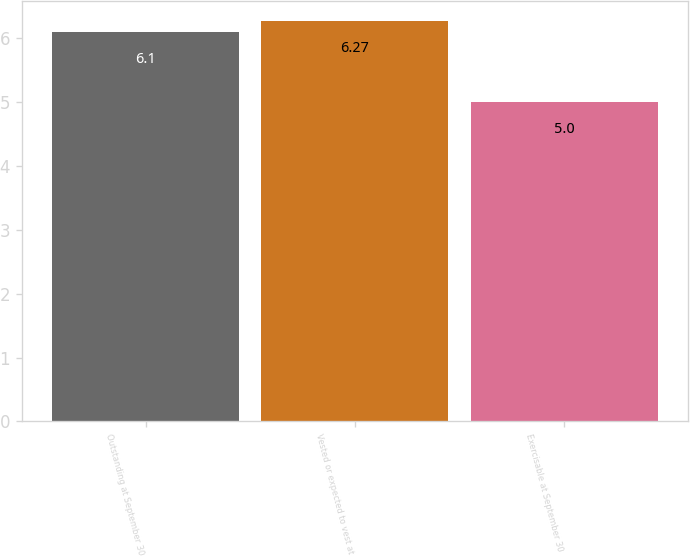Convert chart. <chart><loc_0><loc_0><loc_500><loc_500><bar_chart><fcel>Outstanding at September 30<fcel>Vested or expected to vest at<fcel>Exercisable at September 30<nl><fcel>6.1<fcel>6.27<fcel>5<nl></chart> 